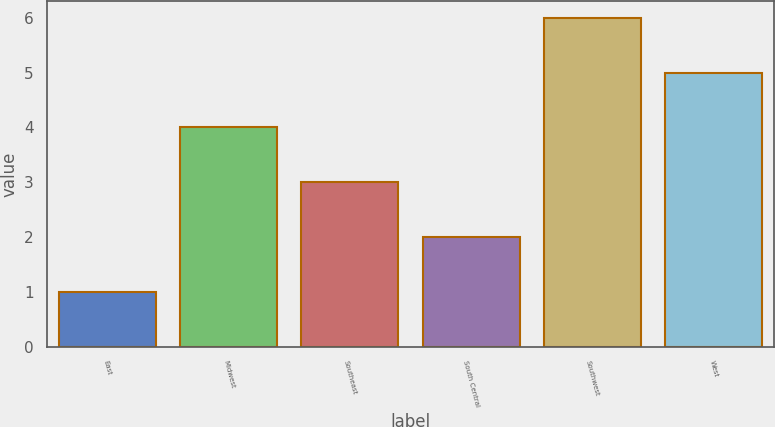<chart> <loc_0><loc_0><loc_500><loc_500><bar_chart><fcel>East<fcel>Midwest<fcel>Southeast<fcel>South Central<fcel>Southwest<fcel>West<nl><fcel>1<fcel>4<fcel>3<fcel>2<fcel>6<fcel>5<nl></chart> 